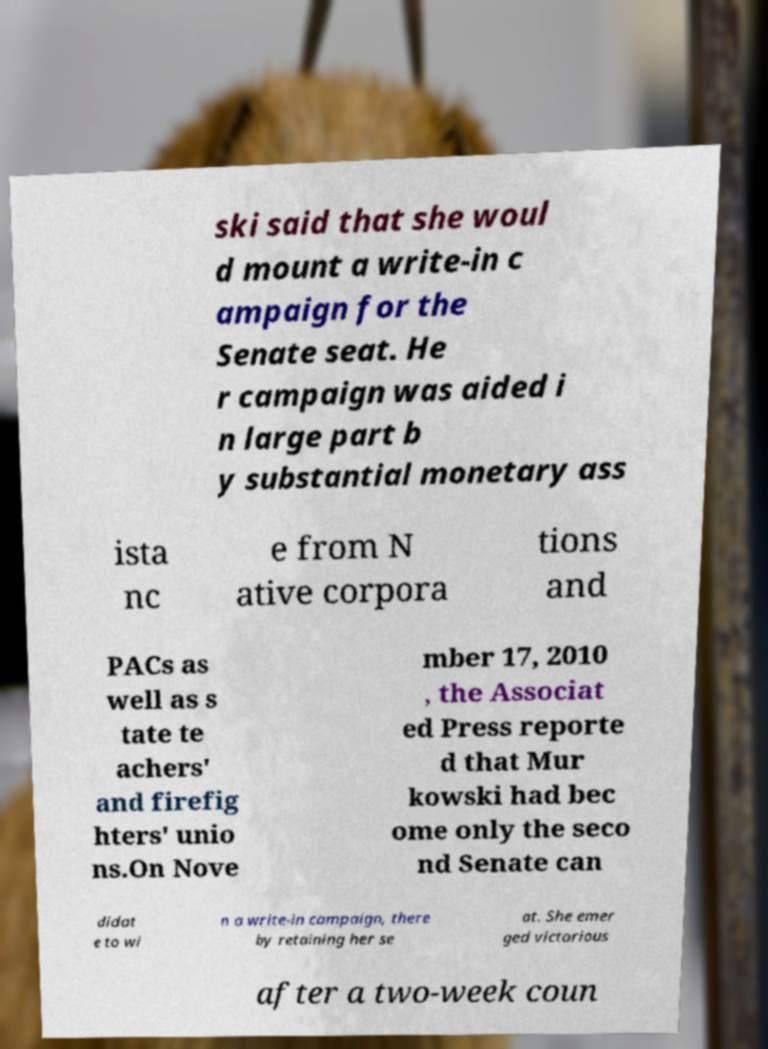Can you accurately transcribe the text from the provided image for me? ski said that she woul d mount a write-in c ampaign for the Senate seat. He r campaign was aided i n large part b y substantial monetary ass ista nc e from N ative corpora tions and PACs as well as s tate te achers' and firefig hters' unio ns.On Nove mber 17, 2010 , the Associat ed Press reporte d that Mur kowski had bec ome only the seco nd Senate can didat e to wi n a write-in campaign, there by retaining her se at. She emer ged victorious after a two-week coun 